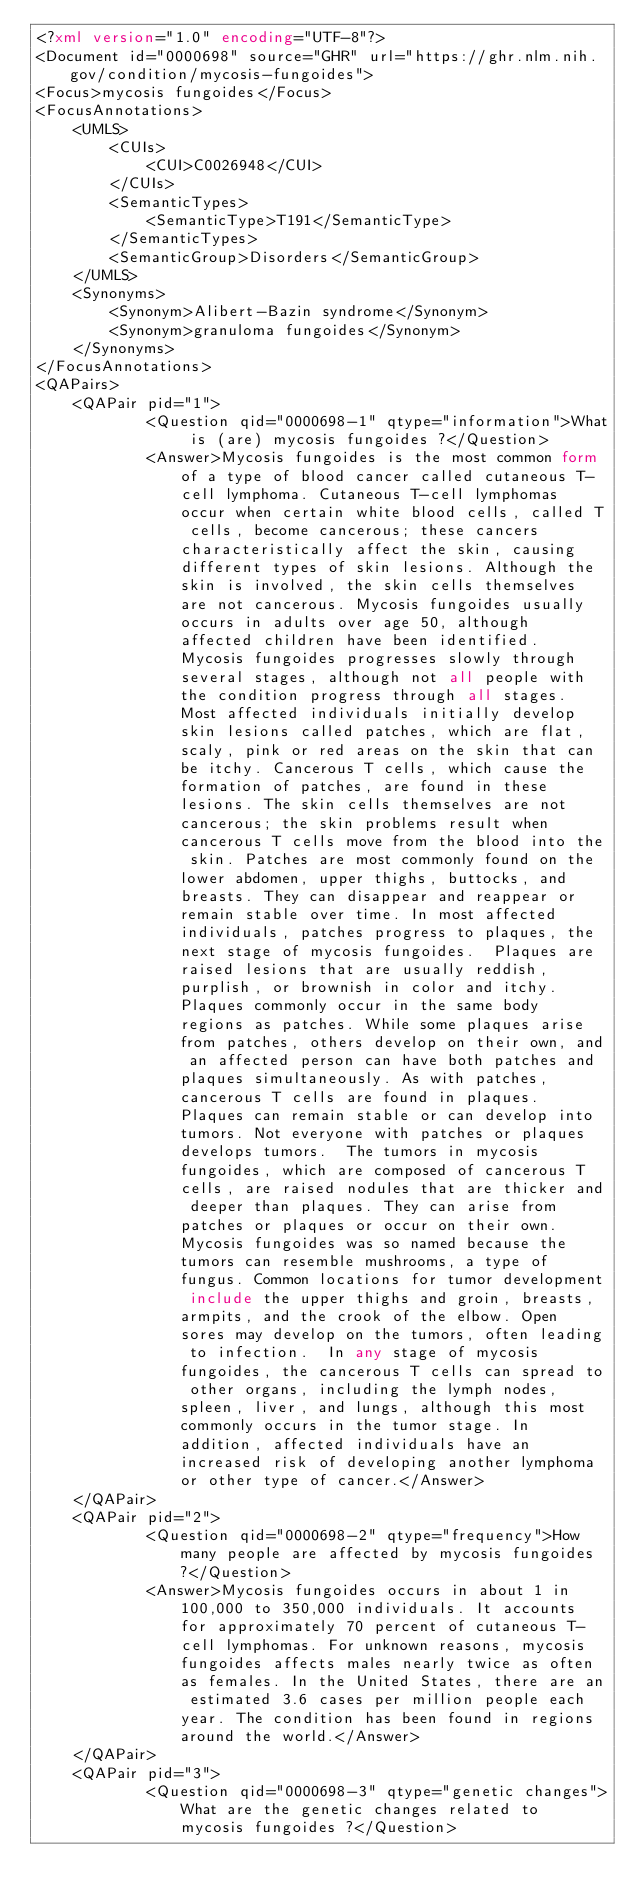Convert code to text. <code><loc_0><loc_0><loc_500><loc_500><_XML_><?xml version="1.0" encoding="UTF-8"?>
<Document id="0000698" source="GHR" url="https://ghr.nlm.nih.gov/condition/mycosis-fungoides">
<Focus>mycosis fungoides</Focus>
<FocusAnnotations>
	<UMLS>
		<CUIs>
			<CUI>C0026948</CUI>
		</CUIs>
		<SemanticTypes>
			<SemanticType>T191</SemanticType>
		</SemanticTypes>
		<SemanticGroup>Disorders</SemanticGroup>
	</UMLS>
	<Synonyms>
		<Synonym>Alibert-Bazin syndrome</Synonym>
		<Synonym>granuloma fungoides</Synonym>
	</Synonyms>
</FocusAnnotations>
<QAPairs>
	<QAPair pid="1">
			<Question qid="0000698-1" qtype="information">What is (are) mycosis fungoides ?</Question>
			<Answer>Mycosis fungoides is the most common form of a type of blood cancer called cutaneous T-cell lymphoma. Cutaneous T-cell lymphomas occur when certain white blood cells, called T cells, become cancerous; these cancers characteristically affect the skin, causing different types of skin lesions. Although the skin is involved, the skin cells themselves are not cancerous. Mycosis fungoides usually occurs in adults over age 50, although affected children have been identified.  Mycosis fungoides progresses slowly through several stages, although not all people with the condition progress through all stages. Most affected individuals initially develop skin lesions called patches, which are flat, scaly, pink or red areas on the skin that can be itchy. Cancerous T cells, which cause the formation of patches, are found in these lesions. The skin cells themselves are not cancerous; the skin problems result when cancerous T cells move from the blood into the skin. Patches are most commonly found on the lower abdomen, upper thighs, buttocks, and breasts. They can disappear and reappear or remain stable over time. In most affected individuals, patches progress to plaques, the next stage of mycosis fungoides.  Plaques are raised lesions that are usually reddish, purplish, or brownish in color and itchy. Plaques commonly occur in the same body regions as patches. While some plaques arise from patches, others develop on their own, and an affected person can have both patches and plaques simultaneously. As with patches, cancerous T cells are found in plaques. Plaques can remain stable or can develop into tumors. Not everyone with patches or plaques develops tumors.  The tumors in mycosis fungoides, which are composed of cancerous T cells, are raised nodules that are thicker and deeper than plaques. They can arise from patches or plaques or occur on their own. Mycosis fungoides was so named because the tumors can resemble mushrooms, a type of fungus. Common locations for tumor development include the upper thighs and groin, breasts, armpits, and the crook of the elbow. Open sores may develop on the tumors, often leading to infection.  In any stage of mycosis fungoides, the cancerous T cells can spread to other organs, including the lymph nodes, spleen, liver, and lungs, although this most commonly occurs in the tumor stage. In addition, affected individuals have an increased risk of developing another lymphoma or other type of cancer.</Answer>
	</QAPair>
	<QAPair pid="2">
			<Question qid="0000698-2" qtype="frequency">How many people are affected by mycosis fungoides ?</Question>
			<Answer>Mycosis fungoides occurs in about 1 in 100,000 to 350,000 individuals. It accounts for approximately 70 percent of cutaneous T-cell lymphomas. For unknown reasons, mycosis fungoides affects males nearly twice as often as females. In the United States, there are an estimated 3.6 cases per million people each year. The condition has been found in regions around the world.</Answer>
	</QAPair>
	<QAPair pid="3">
			<Question qid="0000698-3" qtype="genetic changes">What are the genetic changes related to mycosis fungoides ?</Question></code> 